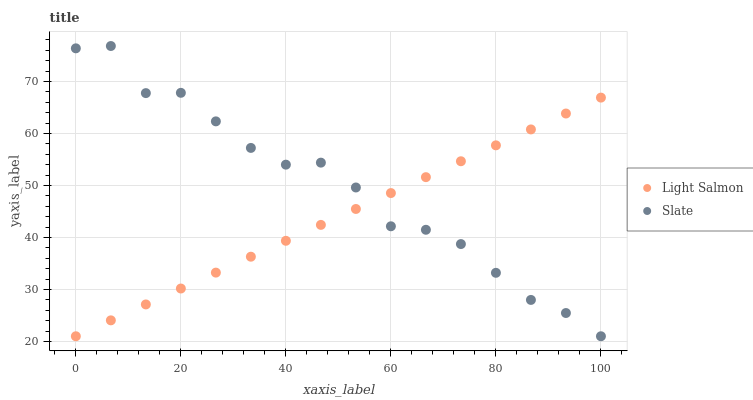Does Light Salmon have the minimum area under the curve?
Answer yes or no. Yes. Does Slate have the maximum area under the curve?
Answer yes or no. Yes. Does Slate have the minimum area under the curve?
Answer yes or no. No. Is Light Salmon the smoothest?
Answer yes or no. Yes. Is Slate the roughest?
Answer yes or no. Yes. Is Slate the smoothest?
Answer yes or no. No. Does Light Salmon have the lowest value?
Answer yes or no. Yes. Does Slate have the highest value?
Answer yes or no. Yes. Does Light Salmon intersect Slate?
Answer yes or no. Yes. Is Light Salmon less than Slate?
Answer yes or no. No. Is Light Salmon greater than Slate?
Answer yes or no. No. 